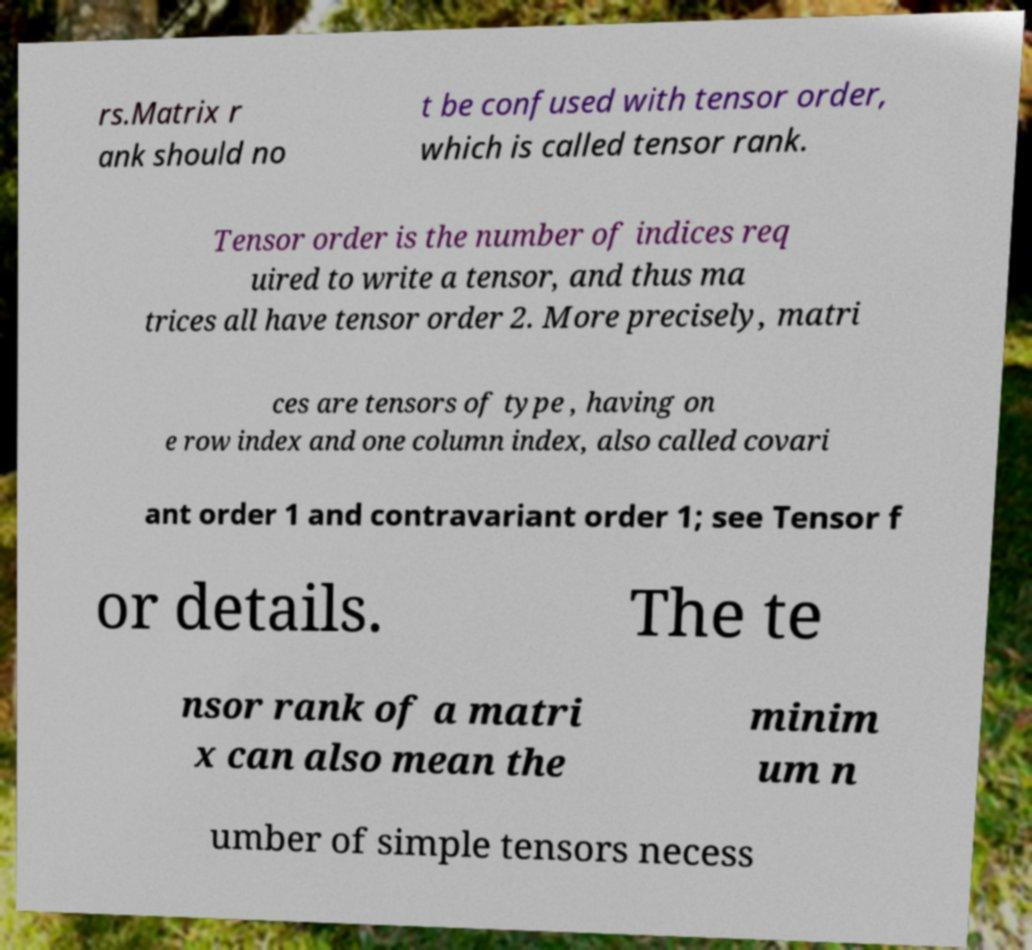Please identify and transcribe the text found in this image. rs.Matrix r ank should no t be confused with tensor order, which is called tensor rank. Tensor order is the number of indices req uired to write a tensor, and thus ma trices all have tensor order 2. More precisely, matri ces are tensors of type , having on e row index and one column index, also called covari ant order 1 and contravariant order 1; see Tensor f or details. The te nsor rank of a matri x can also mean the minim um n umber of simple tensors necess 